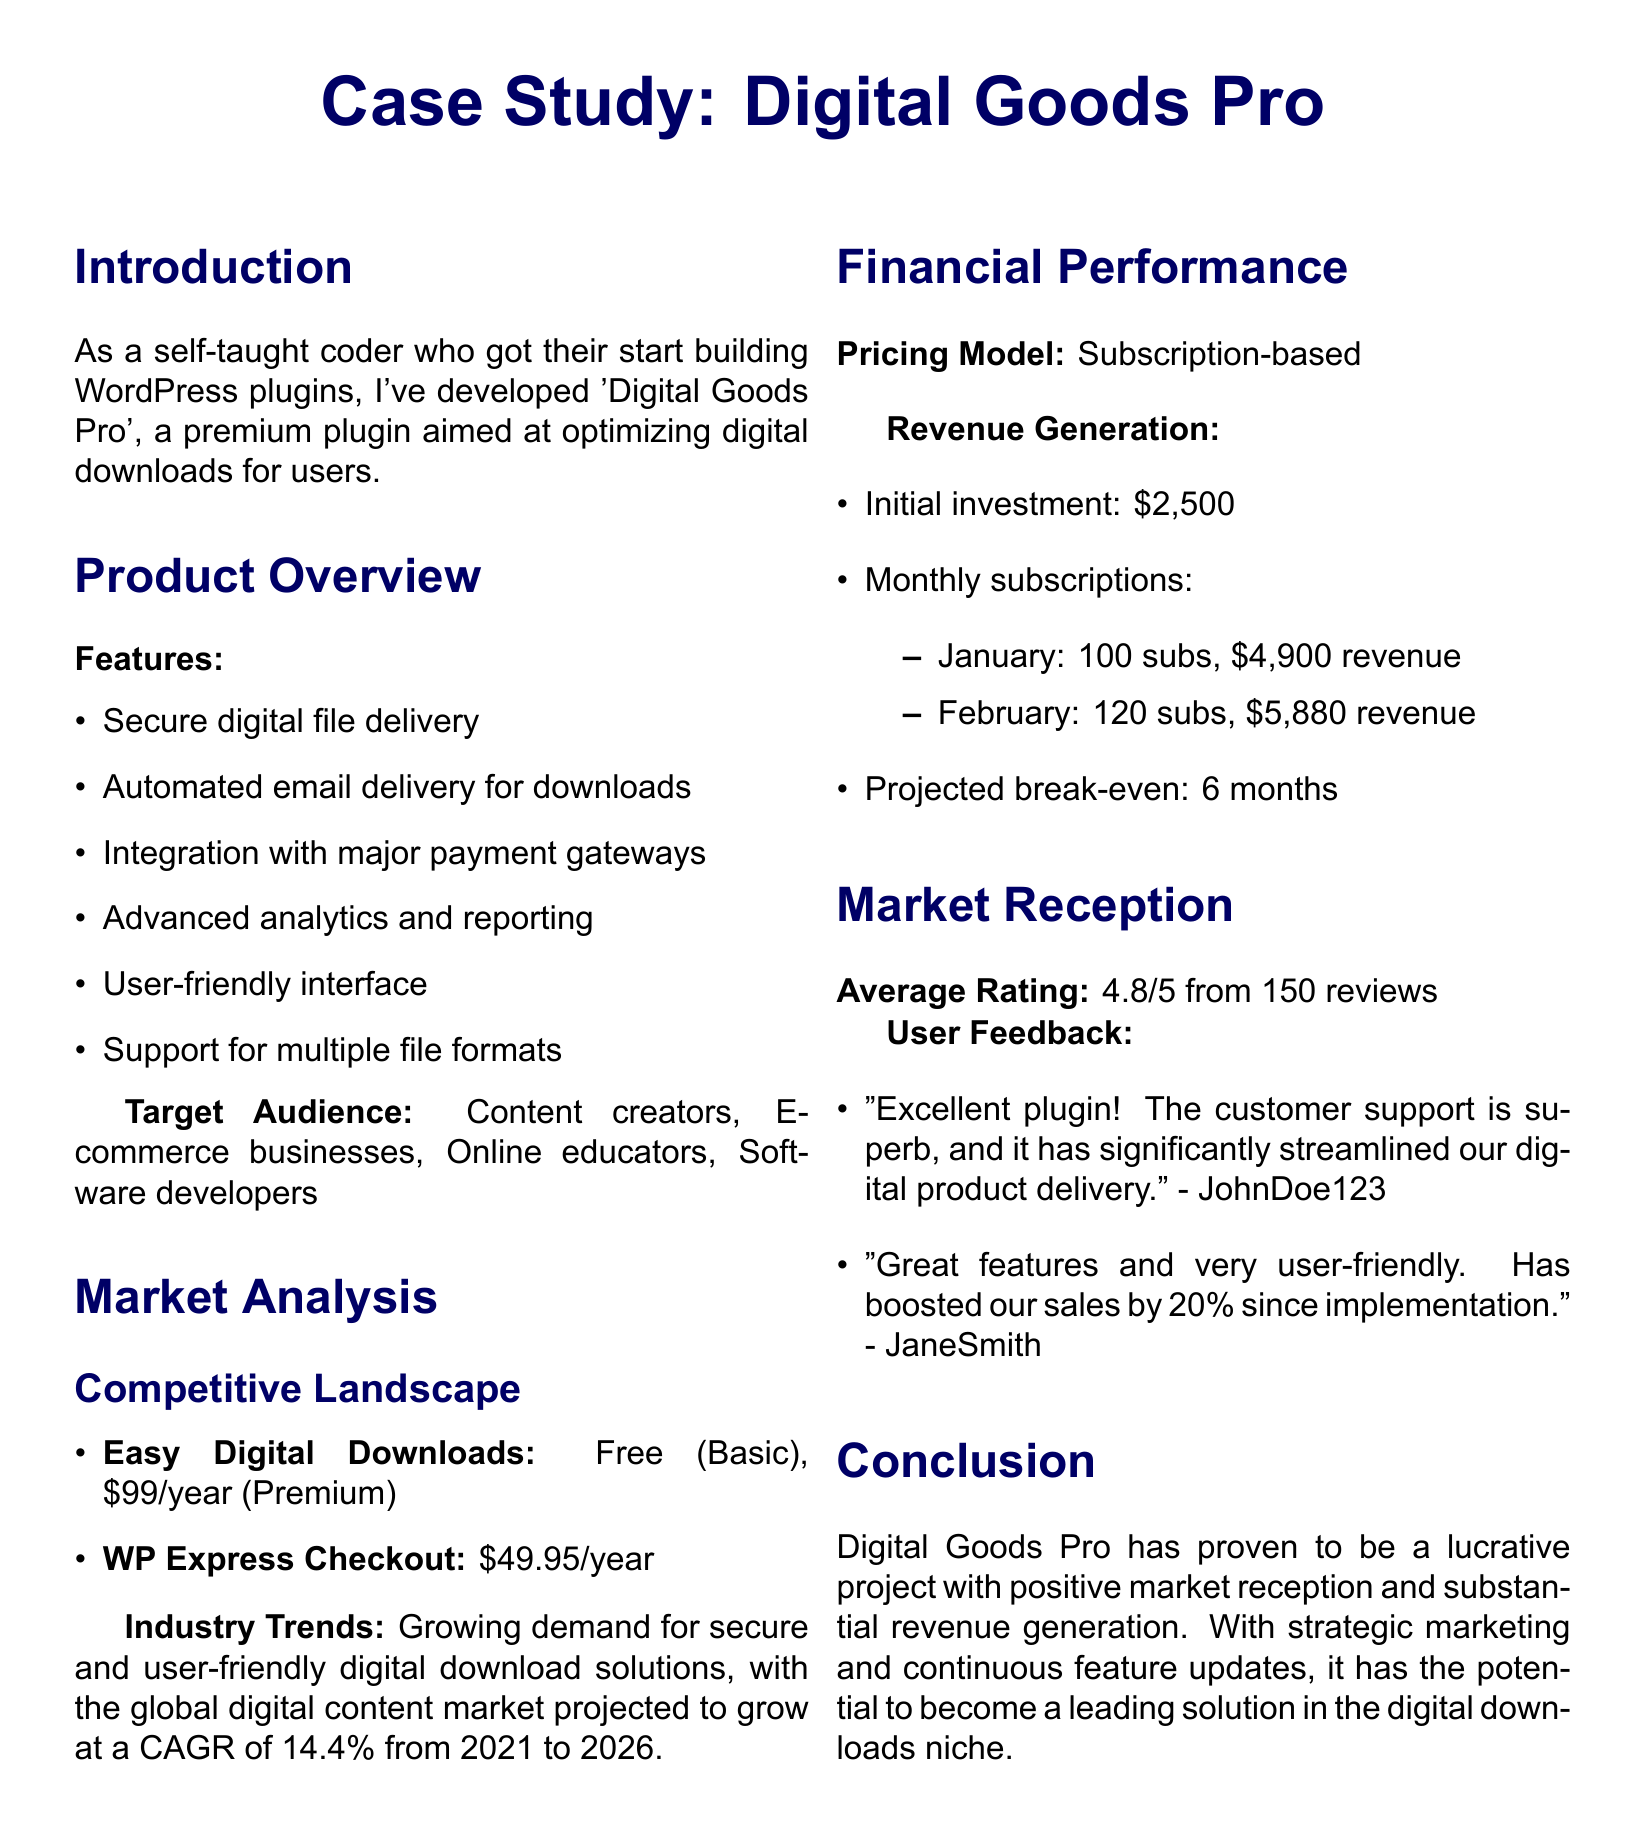What is the name of the premium plugin? The document mentions the premium plugin is called 'Digital Goods Pro'.
Answer: Digital Goods Pro What is the target audience for the plugin? The document lists various groups as the target audience, including content creators and e-commerce businesses.
Answer: Content creators, E-commerce businesses, Online educators, Software developers What is the monthly revenue for February? The February revenue is stated in the document as \$5,880.
Answer: \$5,880 How much is the most expensive subscription tier? The document states the price for the Enterprise tier as \$199/year.
Answer: \$199/year What is the average rating for the plugin? The document indicates that the average rating from reviews is 4.8.
Answer: 4.8/5 What is the initial investment amount listed? The document mentions an initial investment of \$2,500.
Answer: \$2,500 Which feature supports automated email delivery? The document lists "Automated email delivery for downloads" as one of the features.
Answer: Automated email delivery for downloads What percentage did sales increase by according to user feedback? User feedback indicates sales boosted by 20% since implementation.
Answer: 20% What is the competitive landscape example for a free product? "Easy Digital Downloads: Free (Basic)" is mentioned as an example of a competitive landscape.
Answer: Easy Digital Downloads: Free (Basic) 